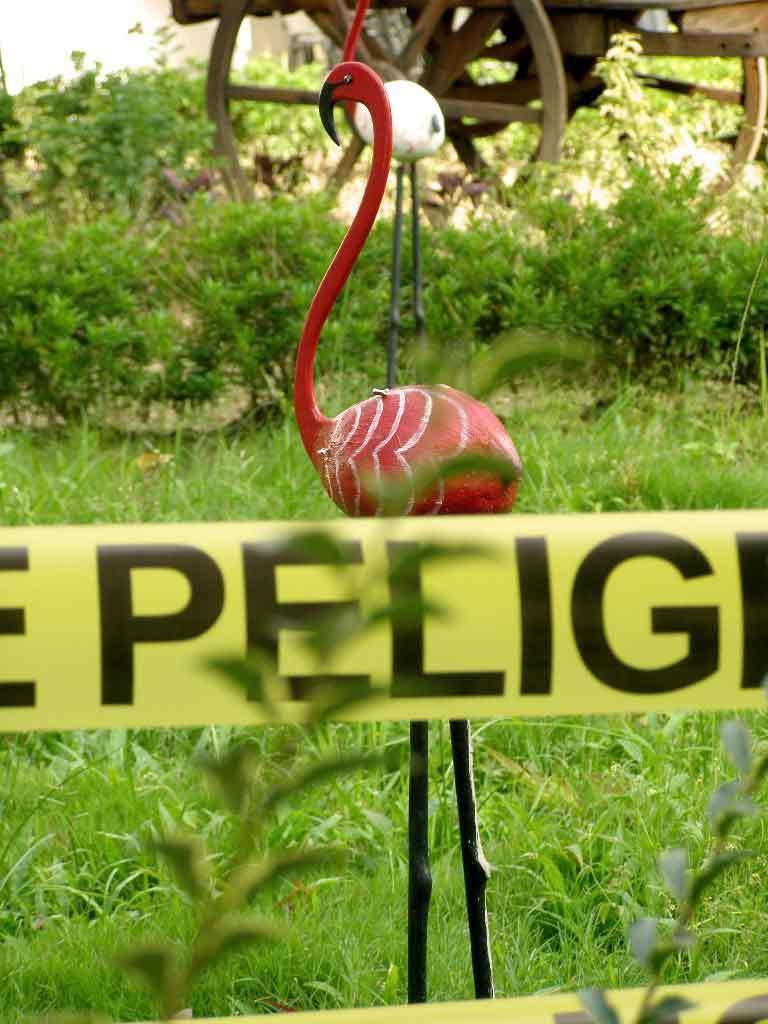Describe this image in one or two sentences. Here we can see grass,plants,small yellow color banner and two birds made with wood on the ground and we can also see two wheels of a vehicle. 